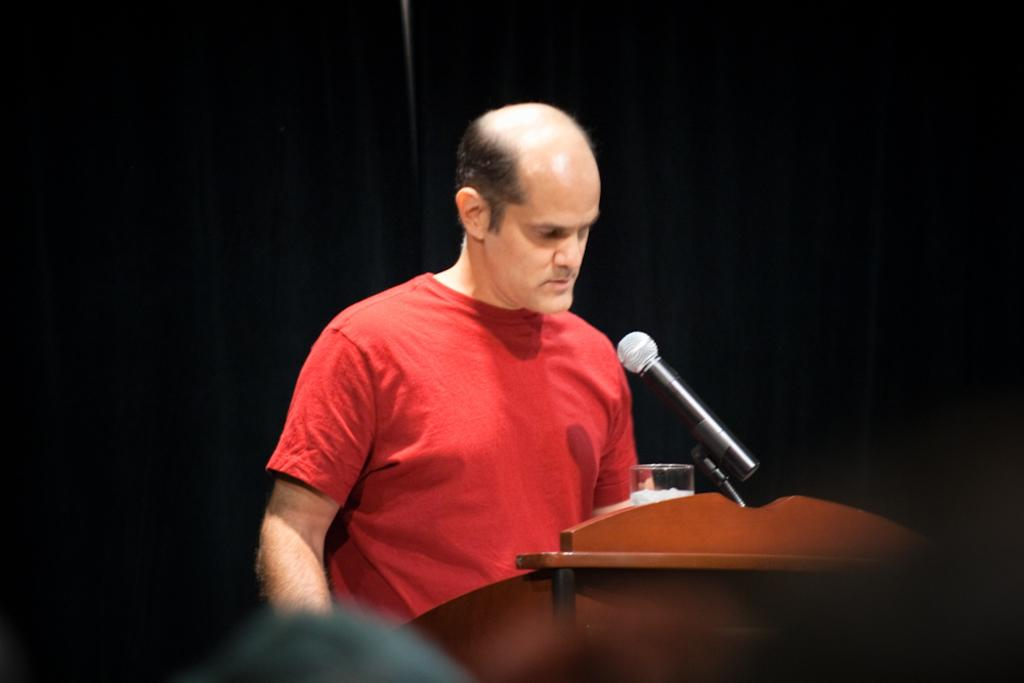What is the man in the image doing? The man is standing at the podium. What is on the podium with the man? There is a microphone and a water glass on the podium. What can be seen in the background of the image? The background of the image appears to be black. What advertisement is being displayed on the podium in the image? There is no advertisement present in the image; it features a man standing at a podium with a microphone and water glass. 